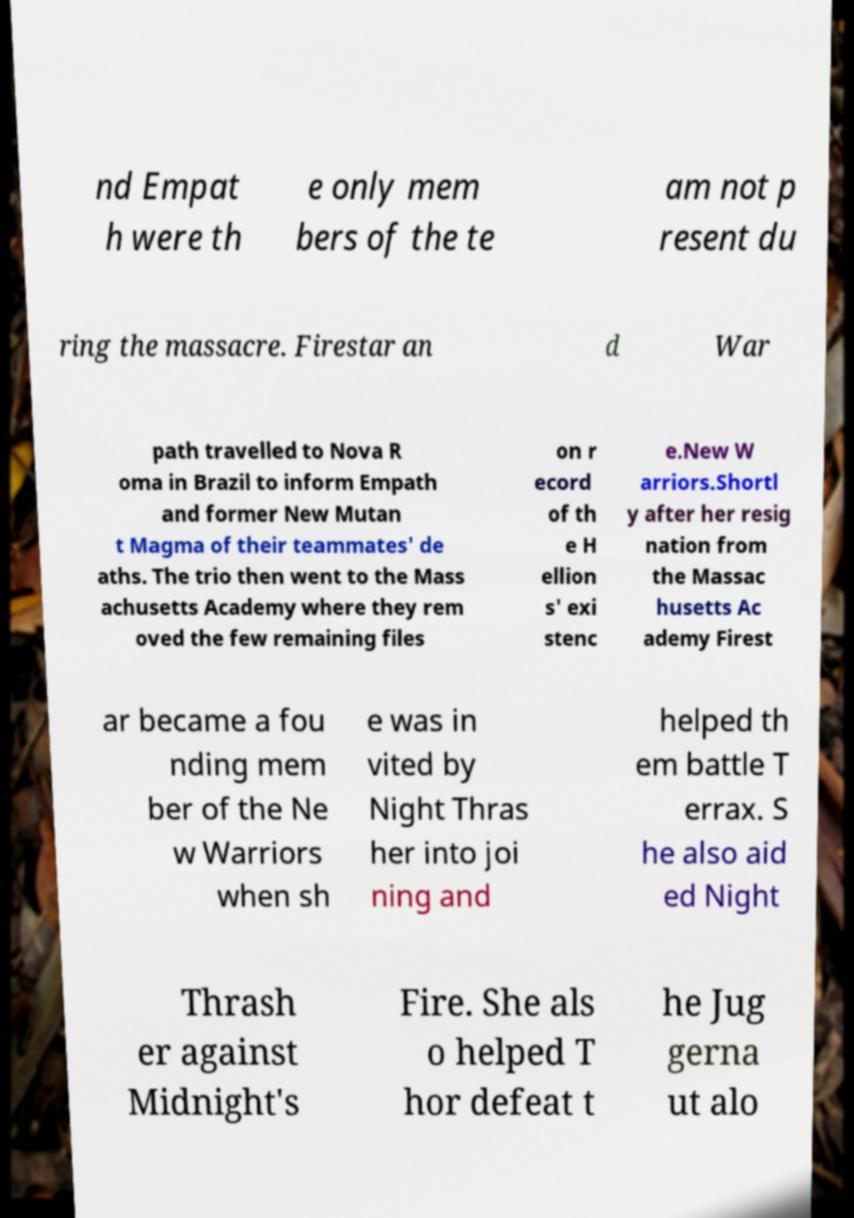Could you extract and type out the text from this image? nd Empat h were th e only mem bers of the te am not p resent du ring the massacre. Firestar an d War path travelled to Nova R oma in Brazil to inform Empath and former New Mutan t Magma of their teammates' de aths. The trio then went to the Mass achusetts Academy where they rem oved the few remaining files on r ecord of th e H ellion s' exi stenc e.New W arriors.Shortl y after her resig nation from the Massac husetts Ac ademy Firest ar became a fou nding mem ber of the Ne w Warriors when sh e was in vited by Night Thras her into joi ning and helped th em battle T errax. S he also aid ed Night Thrash er against Midnight's Fire. She als o helped T hor defeat t he Jug gerna ut alo 